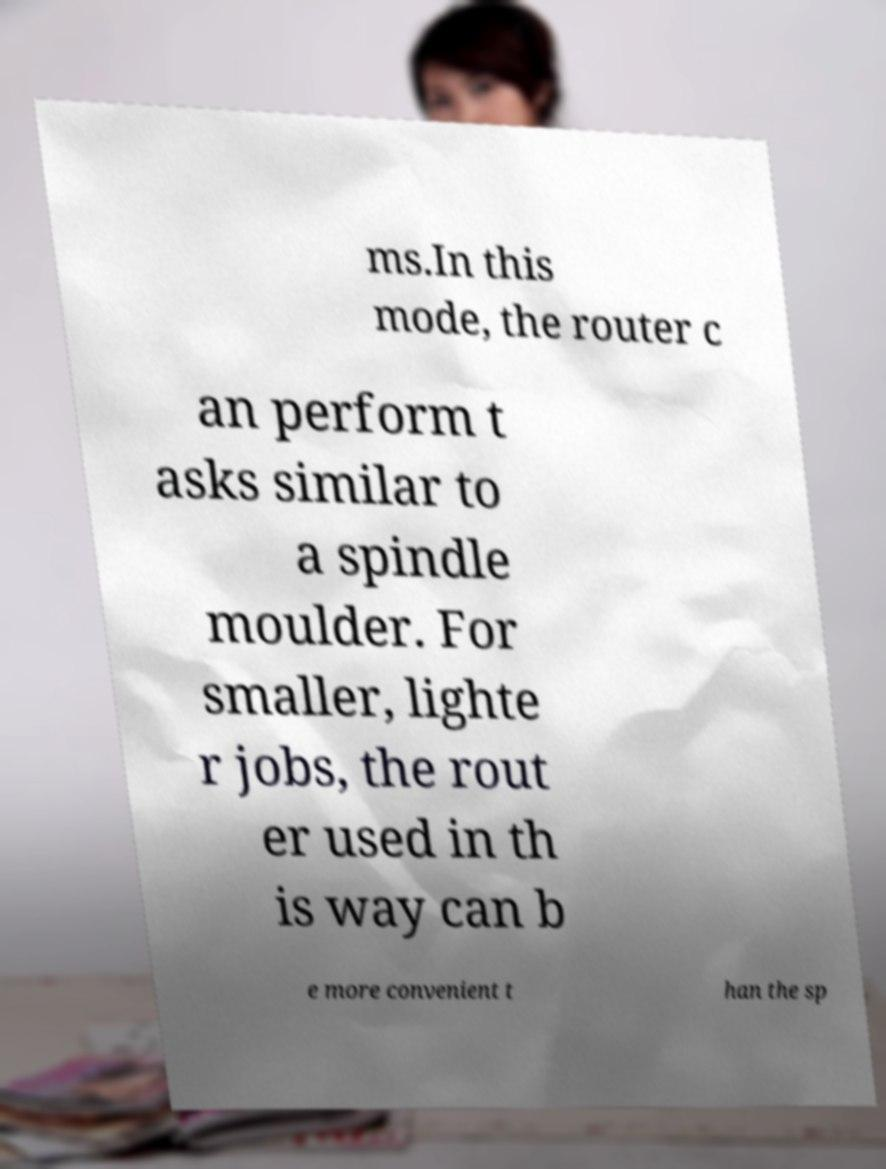Can you accurately transcribe the text from the provided image for me? ms.In this mode, the router c an perform t asks similar to a spindle moulder. For smaller, lighte r jobs, the rout er used in th is way can b e more convenient t han the sp 